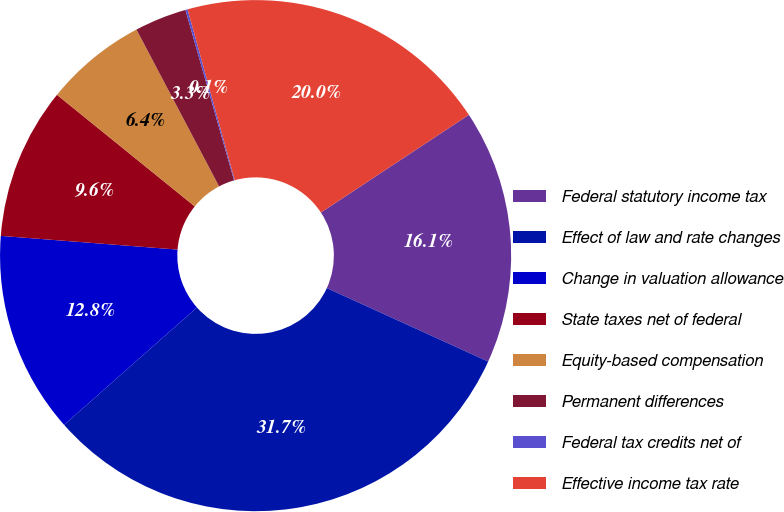Convert chart to OTSL. <chart><loc_0><loc_0><loc_500><loc_500><pie_chart><fcel>Federal statutory income tax<fcel>Effect of law and rate changes<fcel>Change in valuation allowance<fcel>State taxes net of federal<fcel>Equity-based compensation<fcel>Permanent differences<fcel>Federal tax credits net of<fcel>Effective income tax rate<nl><fcel>16.09%<fcel>31.68%<fcel>12.75%<fcel>9.6%<fcel>6.45%<fcel>3.29%<fcel>0.14%<fcel>20.0%<nl></chart> 